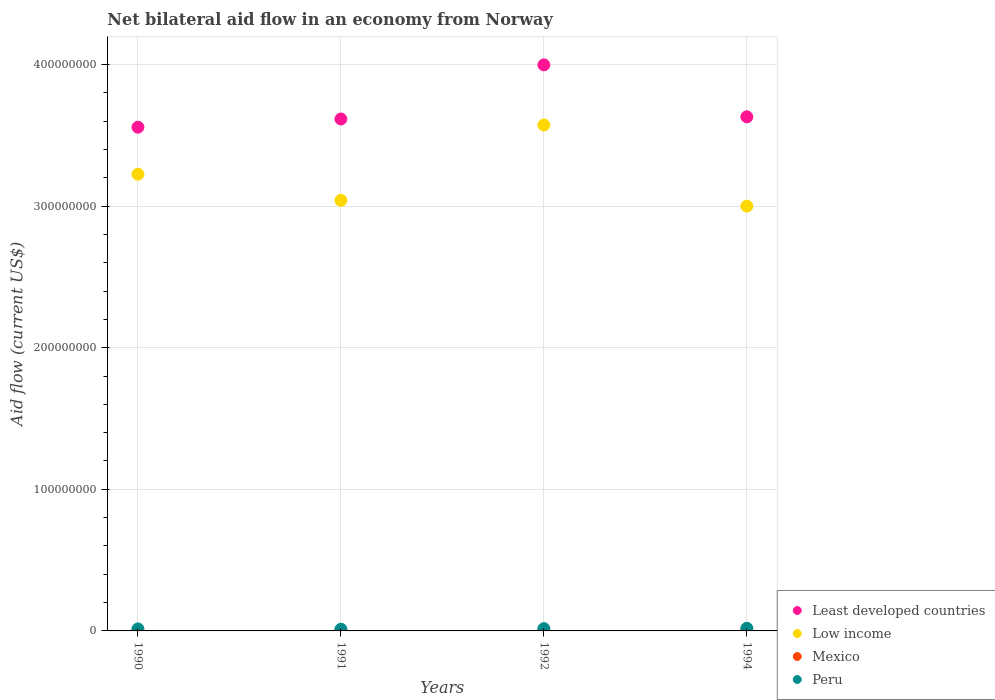Is the number of dotlines equal to the number of legend labels?
Provide a short and direct response. Yes. Across all years, what is the maximum net bilateral aid flow in Least developed countries?
Make the answer very short. 4.00e+08. In which year was the net bilateral aid flow in Peru maximum?
Your answer should be very brief. 1994. What is the total net bilateral aid flow in Peru in the graph?
Your response must be concise. 6.07e+06. What is the difference between the net bilateral aid flow in Low income in 1991 and the net bilateral aid flow in Peru in 1990?
Your answer should be compact. 3.03e+08. What is the average net bilateral aid flow in Peru per year?
Offer a very short reply. 1.52e+06. In the year 1992, what is the difference between the net bilateral aid flow in Peru and net bilateral aid flow in Low income?
Make the answer very short. -3.56e+08. What is the ratio of the net bilateral aid flow in Low income in 1991 to that in 1992?
Keep it short and to the point. 0.85. What is the difference between the highest and the second highest net bilateral aid flow in Least developed countries?
Provide a short and direct response. 3.67e+07. What is the difference between the highest and the lowest net bilateral aid flow in Low income?
Provide a succinct answer. 5.73e+07. Is the sum of the net bilateral aid flow in Peru in 1992 and 1994 greater than the maximum net bilateral aid flow in Mexico across all years?
Make the answer very short. Yes. Is it the case that in every year, the sum of the net bilateral aid flow in Mexico and net bilateral aid flow in Peru  is greater than the net bilateral aid flow in Low income?
Offer a terse response. No. Does the net bilateral aid flow in Mexico monotonically increase over the years?
Provide a succinct answer. No. Is the net bilateral aid flow in Least developed countries strictly greater than the net bilateral aid flow in Low income over the years?
Provide a short and direct response. Yes. How many dotlines are there?
Provide a short and direct response. 4. How many years are there in the graph?
Provide a short and direct response. 4. Does the graph contain any zero values?
Give a very brief answer. No. How many legend labels are there?
Provide a succinct answer. 4. What is the title of the graph?
Your response must be concise. Net bilateral aid flow in an economy from Norway. Does "Guinea" appear as one of the legend labels in the graph?
Your response must be concise. No. What is the Aid flow (current US$) of Least developed countries in 1990?
Give a very brief answer. 3.56e+08. What is the Aid flow (current US$) of Low income in 1990?
Offer a terse response. 3.23e+08. What is the Aid flow (current US$) in Peru in 1990?
Offer a terse response. 1.43e+06. What is the Aid flow (current US$) in Least developed countries in 1991?
Your answer should be very brief. 3.62e+08. What is the Aid flow (current US$) of Low income in 1991?
Provide a short and direct response. 3.04e+08. What is the Aid flow (current US$) in Mexico in 1991?
Your answer should be compact. 1.10e+05. What is the Aid flow (current US$) in Peru in 1991?
Make the answer very short. 1.18e+06. What is the Aid flow (current US$) in Least developed countries in 1992?
Give a very brief answer. 4.00e+08. What is the Aid flow (current US$) in Low income in 1992?
Your response must be concise. 3.57e+08. What is the Aid flow (current US$) in Mexico in 1992?
Your answer should be compact. 3.20e+05. What is the Aid flow (current US$) of Peru in 1992?
Make the answer very short. 1.60e+06. What is the Aid flow (current US$) in Least developed countries in 1994?
Keep it short and to the point. 3.63e+08. What is the Aid flow (current US$) of Low income in 1994?
Ensure brevity in your answer.  3.00e+08. What is the Aid flow (current US$) in Peru in 1994?
Ensure brevity in your answer.  1.86e+06. Across all years, what is the maximum Aid flow (current US$) of Least developed countries?
Your answer should be compact. 4.00e+08. Across all years, what is the maximum Aid flow (current US$) in Low income?
Your answer should be compact. 3.57e+08. Across all years, what is the maximum Aid flow (current US$) in Mexico?
Your response must be concise. 3.50e+05. Across all years, what is the maximum Aid flow (current US$) of Peru?
Ensure brevity in your answer.  1.86e+06. Across all years, what is the minimum Aid flow (current US$) of Least developed countries?
Offer a very short reply. 3.56e+08. Across all years, what is the minimum Aid flow (current US$) of Low income?
Offer a very short reply. 3.00e+08. Across all years, what is the minimum Aid flow (current US$) of Mexico?
Ensure brevity in your answer.  1.10e+05. Across all years, what is the minimum Aid flow (current US$) of Peru?
Your answer should be very brief. 1.18e+06. What is the total Aid flow (current US$) in Least developed countries in the graph?
Offer a terse response. 1.48e+09. What is the total Aid flow (current US$) in Low income in the graph?
Offer a terse response. 1.28e+09. What is the total Aid flow (current US$) in Mexico in the graph?
Offer a very short reply. 9.50e+05. What is the total Aid flow (current US$) in Peru in the graph?
Provide a succinct answer. 6.07e+06. What is the difference between the Aid flow (current US$) of Least developed countries in 1990 and that in 1991?
Provide a short and direct response. -5.80e+06. What is the difference between the Aid flow (current US$) in Low income in 1990 and that in 1991?
Provide a short and direct response. 1.85e+07. What is the difference between the Aid flow (current US$) in Mexico in 1990 and that in 1991?
Keep it short and to the point. 6.00e+04. What is the difference between the Aid flow (current US$) of Least developed countries in 1990 and that in 1992?
Your answer should be very brief. -4.40e+07. What is the difference between the Aid flow (current US$) of Low income in 1990 and that in 1992?
Give a very brief answer. -3.48e+07. What is the difference between the Aid flow (current US$) of Least developed countries in 1990 and that in 1994?
Offer a very short reply. -7.33e+06. What is the difference between the Aid flow (current US$) in Low income in 1990 and that in 1994?
Provide a short and direct response. 2.26e+07. What is the difference between the Aid flow (current US$) in Peru in 1990 and that in 1994?
Make the answer very short. -4.30e+05. What is the difference between the Aid flow (current US$) in Least developed countries in 1991 and that in 1992?
Ensure brevity in your answer.  -3.82e+07. What is the difference between the Aid flow (current US$) of Low income in 1991 and that in 1992?
Offer a very short reply. -5.32e+07. What is the difference between the Aid flow (current US$) in Mexico in 1991 and that in 1992?
Give a very brief answer. -2.10e+05. What is the difference between the Aid flow (current US$) in Peru in 1991 and that in 1992?
Provide a succinct answer. -4.20e+05. What is the difference between the Aid flow (current US$) of Least developed countries in 1991 and that in 1994?
Provide a succinct answer. -1.53e+06. What is the difference between the Aid flow (current US$) in Low income in 1991 and that in 1994?
Give a very brief answer. 4.09e+06. What is the difference between the Aid flow (current US$) in Peru in 1991 and that in 1994?
Ensure brevity in your answer.  -6.80e+05. What is the difference between the Aid flow (current US$) of Least developed countries in 1992 and that in 1994?
Make the answer very short. 3.67e+07. What is the difference between the Aid flow (current US$) of Low income in 1992 and that in 1994?
Offer a terse response. 5.73e+07. What is the difference between the Aid flow (current US$) of Mexico in 1992 and that in 1994?
Provide a short and direct response. -3.00e+04. What is the difference between the Aid flow (current US$) in Peru in 1992 and that in 1994?
Provide a short and direct response. -2.60e+05. What is the difference between the Aid flow (current US$) of Least developed countries in 1990 and the Aid flow (current US$) of Low income in 1991?
Your answer should be compact. 5.16e+07. What is the difference between the Aid flow (current US$) in Least developed countries in 1990 and the Aid flow (current US$) in Mexico in 1991?
Offer a terse response. 3.56e+08. What is the difference between the Aid flow (current US$) in Least developed countries in 1990 and the Aid flow (current US$) in Peru in 1991?
Your answer should be compact. 3.55e+08. What is the difference between the Aid flow (current US$) of Low income in 1990 and the Aid flow (current US$) of Mexico in 1991?
Keep it short and to the point. 3.22e+08. What is the difference between the Aid flow (current US$) in Low income in 1990 and the Aid flow (current US$) in Peru in 1991?
Provide a succinct answer. 3.21e+08. What is the difference between the Aid flow (current US$) in Mexico in 1990 and the Aid flow (current US$) in Peru in 1991?
Offer a very short reply. -1.01e+06. What is the difference between the Aid flow (current US$) in Least developed countries in 1990 and the Aid flow (current US$) in Low income in 1992?
Give a very brief answer. -1.57e+06. What is the difference between the Aid flow (current US$) of Least developed countries in 1990 and the Aid flow (current US$) of Mexico in 1992?
Your response must be concise. 3.55e+08. What is the difference between the Aid flow (current US$) in Least developed countries in 1990 and the Aid flow (current US$) in Peru in 1992?
Your answer should be very brief. 3.54e+08. What is the difference between the Aid flow (current US$) of Low income in 1990 and the Aid flow (current US$) of Mexico in 1992?
Keep it short and to the point. 3.22e+08. What is the difference between the Aid flow (current US$) in Low income in 1990 and the Aid flow (current US$) in Peru in 1992?
Your answer should be compact. 3.21e+08. What is the difference between the Aid flow (current US$) in Mexico in 1990 and the Aid flow (current US$) in Peru in 1992?
Offer a very short reply. -1.43e+06. What is the difference between the Aid flow (current US$) of Least developed countries in 1990 and the Aid flow (current US$) of Low income in 1994?
Your response must be concise. 5.57e+07. What is the difference between the Aid flow (current US$) in Least developed countries in 1990 and the Aid flow (current US$) in Mexico in 1994?
Offer a very short reply. 3.55e+08. What is the difference between the Aid flow (current US$) in Least developed countries in 1990 and the Aid flow (current US$) in Peru in 1994?
Your answer should be compact. 3.54e+08. What is the difference between the Aid flow (current US$) in Low income in 1990 and the Aid flow (current US$) in Mexico in 1994?
Keep it short and to the point. 3.22e+08. What is the difference between the Aid flow (current US$) of Low income in 1990 and the Aid flow (current US$) of Peru in 1994?
Offer a very short reply. 3.21e+08. What is the difference between the Aid flow (current US$) in Mexico in 1990 and the Aid flow (current US$) in Peru in 1994?
Offer a very short reply. -1.69e+06. What is the difference between the Aid flow (current US$) of Least developed countries in 1991 and the Aid flow (current US$) of Low income in 1992?
Your answer should be very brief. 4.23e+06. What is the difference between the Aid flow (current US$) of Least developed countries in 1991 and the Aid flow (current US$) of Mexico in 1992?
Give a very brief answer. 3.61e+08. What is the difference between the Aid flow (current US$) in Least developed countries in 1991 and the Aid flow (current US$) in Peru in 1992?
Offer a very short reply. 3.60e+08. What is the difference between the Aid flow (current US$) of Low income in 1991 and the Aid flow (current US$) of Mexico in 1992?
Offer a terse response. 3.04e+08. What is the difference between the Aid flow (current US$) of Low income in 1991 and the Aid flow (current US$) of Peru in 1992?
Offer a terse response. 3.02e+08. What is the difference between the Aid flow (current US$) of Mexico in 1991 and the Aid flow (current US$) of Peru in 1992?
Your response must be concise. -1.49e+06. What is the difference between the Aid flow (current US$) in Least developed countries in 1991 and the Aid flow (current US$) in Low income in 1994?
Ensure brevity in your answer.  6.15e+07. What is the difference between the Aid flow (current US$) of Least developed countries in 1991 and the Aid flow (current US$) of Mexico in 1994?
Give a very brief answer. 3.61e+08. What is the difference between the Aid flow (current US$) in Least developed countries in 1991 and the Aid flow (current US$) in Peru in 1994?
Keep it short and to the point. 3.60e+08. What is the difference between the Aid flow (current US$) of Low income in 1991 and the Aid flow (current US$) of Mexico in 1994?
Ensure brevity in your answer.  3.04e+08. What is the difference between the Aid flow (current US$) of Low income in 1991 and the Aid flow (current US$) of Peru in 1994?
Offer a very short reply. 3.02e+08. What is the difference between the Aid flow (current US$) of Mexico in 1991 and the Aid flow (current US$) of Peru in 1994?
Provide a succinct answer. -1.75e+06. What is the difference between the Aid flow (current US$) of Least developed countries in 1992 and the Aid flow (current US$) of Low income in 1994?
Make the answer very short. 9.98e+07. What is the difference between the Aid flow (current US$) in Least developed countries in 1992 and the Aid flow (current US$) in Mexico in 1994?
Provide a succinct answer. 3.99e+08. What is the difference between the Aid flow (current US$) of Least developed countries in 1992 and the Aid flow (current US$) of Peru in 1994?
Your answer should be compact. 3.98e+08. What is the difference between the Aid flow (current US$) of Low income in 1992 and the Aid flow (current US$) of Mexico in 1994?
Your answer should be compact. 3.57e+08. What is the difference between the Aid flow (current US$) in Low income in 1992 and the Aid flow (current US$) in Peru in 1994?
Keep it short and to the point. 3.55e+08. What is the difference between the Aid flow (current US$) in Mexico in 1992 and the Aid flow (current US$) in Peru in 1994?
Give a very brief answer. -1.54e+06. What is the average Aid flow (current US$) in Least developed countries per year?
Offer a very short reply. 3.70e+08. What is the average Aid flow (current US$) of Low income per year?
Offer a very short reply. 3.21e+08. What is the average Aid flow (current US$) in Mexico per year?
Provide a succinct answer. 2.38e+05. What is the average Aid flow (current US$) of Peru per year?
Your response must be concise. 1.52e+06. In the year 1990, what is the difference between the Aid flow (current US$) of Least developed countries and Aid flow (current US$) of Low income?
Give a very brief answer. 3.32e+07. In the year 1990, what is the difference between the Aid flow (current US$) of Least developed countries and Aid flow (current US$) of Mexico?
Give a very brief answer. 3.56e+08. In the year 1990, what is the difference between the Aid flow (current US$) in Least developed countries and Aid flow (current US$) in Peru?
Your response must be concise. 3.54e+08. In the year 1990, what is the difference between the Aid flow (current US$) in Low income and Aid flow (current US$) in Mexico?
Ensure brevity in your answer.  3.22e+08. In the year 1990, what is the difference between the Aid flow (current US$) of Low income and Aid flow (current US$) of Peru?
Offer a terse response. 3.21e+08. In the year 1990, what is the difference between the Aid flow (current US$) in Mexico and Aid flow (current US$) in Peru?
Make the answer very short. -1.26e+06. In the year 1991, what is the difference between the Aid flow (current US$) of Least developed countries and Aid flow (current US$) of Low income?
Ensure brevity in your answer.  5.74e+07. In the year 1991, what is the difference between the Aid flow (current US$) of Least developed countries and Aid flow (current US$) of Mexico?
Give a very brief answer. 3.61e+08. In the year 1991, what is the difference between the Aid flow (current US$) of Least developed countries and Aid flow (current US$) of Peru?
Provide a succinct answer. 3.60e+08. In the year 1991, what is the difference between the Aid flow (current US$) in Low income and Aid flow (current US$) in Mexico?
Provide a succinct answer. 3.04e+08. In the year 1991, what is the difference between the Aid flow (current US$) in Low income and Aid flow (current US$) in Peru?
Provide a succinct answer. 3.03e+08. In the year 1991, what is the difference between the Aid flow (current US$) in Mexico and Aid flow (current US$) in Peru?
Your response must be concise. -1.07e+06. In the year 1992, what is the difference between the Aid flow (current US$) of Least developed countries and Aid flow (current US$) of Low income?
Give a very brief answer. 4.24e+07. In the year 1992, what is the difference between the Aid flow (current US$) of Least developed countries and Aid flow (current US$) of Mexico?
Keep it short and to the point. 3.99e+08. In the year 1992, what is the difference between the Aid flow (current US$) in Least developed countries and Aid flow (current US$) in Peru?
Provide a short and direct response. 3.98e+08. In the year 1992, what is the difference between the Aid flow (current US$) of Low income and Aid flow (current US$) of Mexico?
Your answer should be compact. 3.57e+08. In the year 1992, what is the difference between the Aid flow (current US$) in Low income and Aid flow (current US$) in Peru?
Your answer should be very brief. 3.56e+08. In the year 1992, what is the difference between the Aid flow (current US$) of Mexico and Aid flow (current US$) of Peru?
Ensure brevity in your answer.  -1.28e+06. In the year 1994, what is the difference between the Aid flow (current US$) of Least developed countries and Aid flow (current US$) of Low income?
Provide a short and direct response. 6.31e+07. In the year 1994, what is the difference between the Aid flow (current US$) of Least developed countries and Aid flow (current US$) of Mexico?
Provide a short and direct response. 3.63e+08. In the year 1994, what is the difference between the Aid flow (current US$) in Least developed countries and Aid flow (current US$) in Peru?
Your answer should be very brief. 3.61e+08. In the year 1994, what is the difference between the Aid flow (current US$) of Low income and Aid flow (current US$) of Mexico?
Offer a very short reply. 3.00e+08. In the year 1994, what is the difference between the Aid flow (current US$) in Low income and Aid flow (current US$) in Peru?
Ensure brevity in your answer.  2.98e+08. In the year 1994, what is the difference between the Aid flow (current US$) of Mexico and Aid flow (current US$) of Peru?
Give a very brief answer. -1.51e+06. What is the ratio of the Aid flow (current US$) of Low income in 1990 to that in 1991?
Your answer should be very brief. 1.06. What is the ratio of the Aid flow (current US$) in Mexico in 1990 to that in 1991?
Give a very brief answer. 1.55. What is the ratio of the Aid flow (current US$) of Peru in 1990 to that in 1991?
Give a very brief answer. 1.21. What is the ratio of the Aid flow (current US$) of Least developed countries in 1990 to that in 1992?
Offer a terse response. 0.89. What is the ratio of the Aid flow (current US$) of Low income in 1990 to that in 1992?
Your answer should be very brief. 0.9. What is the ratio of the Aid flow (current US$) of Mexico in 1990 to that in 1992?
Make the answer very short. 0.53. What is the ratio of the Aid flow (current US$) of Peru in 1990 to that in 1992?
Provide a succinct answer. 0.89. What is the ratio of the Aid flow (current US$) in Least developed countries in 1990 to that in 1994?
Your answer should be compact. 0.98. What is the ratio of the Aid flow (current US$) in Low income in 1990 to that in 1994?
Give a very brief answer. 1.08. What is the ratio of the Aid flow (current US$) of Mexico in 1990 to that in 1994?
Keep it short and to the point. 0.49. What is the ratio of the Aid flow (current US$) in Peru in 1990 to that in 1994?
Offer a very short reply. 0.77. What is the ratio of the Aid flow (current US$) in Least developed countries in 1991 to that in 1992?
Ensure brevity in your answer.  0.9. What is the ratio of the Aid flow (current US$) in Low income in 1991 to that in 1992?
Keep it short and to the point. 0.85. What is the ratio of the Aid flow (current US$) of Mexico in 1991 to that in 1992?
Provide a succinct answer. 0.34. What is the ratio of the Aid flow (current US$) in Peru in 1991 to that in 1992?
Ensure brevity in your answer.  0.74. What is the ratio of the Aid flow (current US$) of Least developed countries in 1991 to that in 1994?
Give a very brief answer. 1. What is the ratio of the Aid flow (current US$) of Low income in 1991 to that in 1994?
Your answer should be very brief. 1.01. What is the ratio of the Aid flow (current US$) in Mexico in 1991 to that in 1994?
Keep it short and to the point. 0.31. What is the ratio of the Aid flow (current US$) of Peru in 1991 to that in 1994?
Give a very brief answer. 0.63. What is the ratio of the Aid flow (current US$) of Least developed countries in 1992 to that in 1994?
Your answer should be very brief. 1.1. What is the ratio of the Aid flow (current US$) in Low income in 1992 to that in 1994?
Provide a short and direct response. 1.19. What is the ratio of the Aid flow (current US$) of Mexico in 1992 to that in 1994?
Keep it short and to the point. 0.91. What is the ratio of the Aid flow (current US$) in Peru in 1992 to that in 1994?
Your response must be concise. 0.86. What is the difference between the highest and the second highest Aid flow (current US$) of Least developed countries?
Your answer should be very brief. 3.67e+07. What is the difference between the highest and the second highest Aid flow (current US$) of Low income?
Keep it short and to the point. 3.48e+07. What is the difference between the highest and the second highest Aid flow (current US$) in Mexico?
Your answer should be very brief. 3.00e+04. What is the difference between the highest and the lowest Aid flow (current US$) in Least developed countries?
Ensure brevity in your answer.  4.40e+07. What is the difference between the highest and the lowest Aid flow (current US$) of Low income?
Provide a succinct answer. 5.73e+07. What is the difference between the highest and the lowest Aid flow (current US$) of Peru?
Provide a short and direct response. 6.80e+05. 